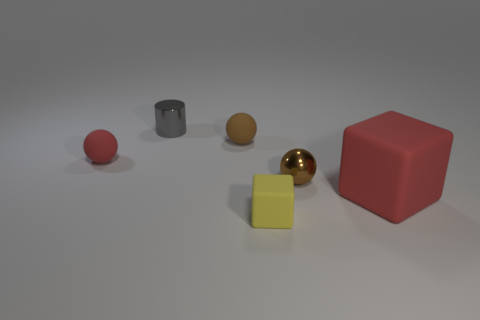Subtract all matte spheres. How many spheres are left? 1 Subtract all red spheres. How many spheres are left? 2 Add 1 tiny green metallic things. How many objects exist? 7 Subtract all cylinders. How many objects are left? 5 Subtract 2 balls. How many balls are left? 1 Subtract all red cylinders. Subtract all brown balls. How many cylinders are left? 1 Subtract all yellow balls. How many brown cubes are left? 0 Subtract all small brown matte spheres. Subtract all brown rubber objects. How many objects are left? 4 Add 5 tiny brown matte spheres. How many tiny brown matte spheres are left? 6 Add 3 brown shiny cylinders. How many brown shiny cylinders exist? 3 